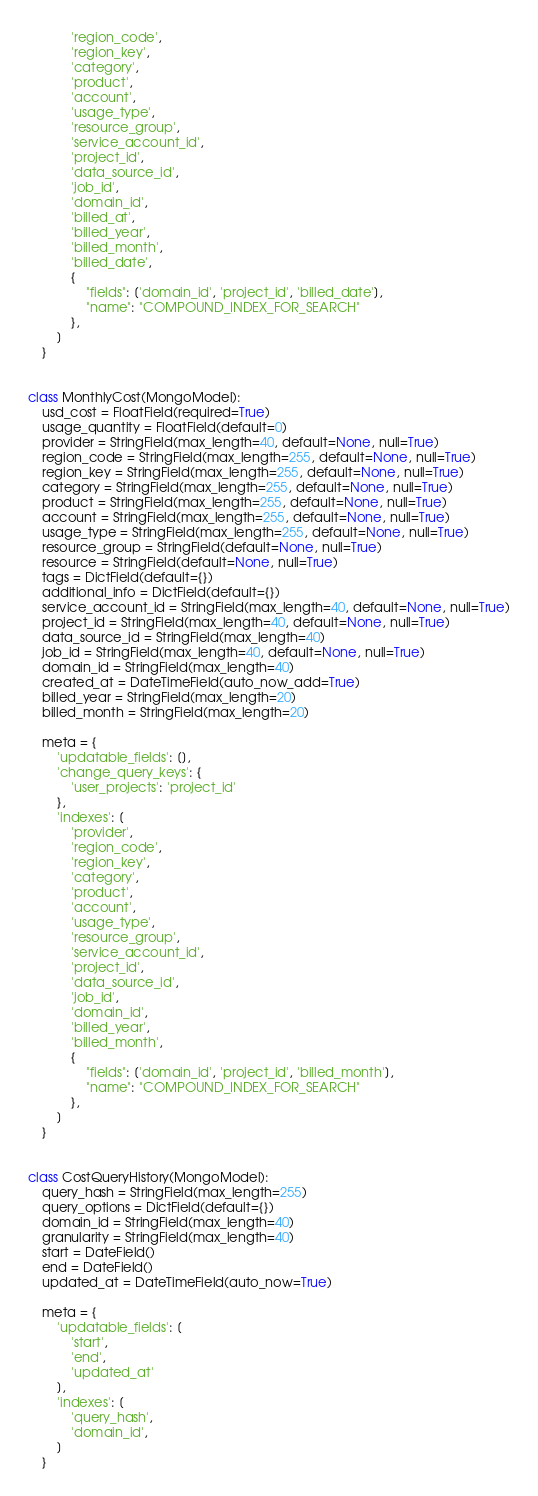<code> <loc_0><loc_0><loc_500><loc_500><_Python_>            'region_code',
            'region_key',
            'category',
            'product',
            'account',
            'usage_type',
            'resource_group',
            'service_account_id',
            'project_id',
            'data_source_id',
            'job_id',
            'domain_id',
            'billed_at',
            'billed_year',
            'billed_month',
            'billed_date',
            {
                "fields": ['domain_id', 'project_id', 'billed_date'],
                "name": "COMPOUND_INDEX_FOR_SEARCH"
            },
        ]
    }


class MonthlyCost(MongoModel):
    usd_cost = FloatField(required=True)
    usage_quantity = FloatField(default=0)
    provider = StringField(max_length=40, default=None, null=True)
    region_code = StringField(max_length=255, default=None, null=True)
    region_key = StringField(max_length=255, default=None, null=True)
    category = StringField(max_length=255, default=None, null=True)
    product = StringField(max_length=255, default=None, null=True)
    account = StringField(max_length=255, default=None, null=True)
    usage_type = StringField(max_length=255, default=None, null=True)
    resource_group = StringField(default=None, null=True)
    resource = StringField(default=None, null=True)
    tags = DictField(default={})
    additional_info = DictField(default={})
    service_account_id = StringField(max_length=40, default=None, null=True)
    project_id = StringField(max_length=40, default=None, null=True)
    data_source_id = StringField(max_length=40)
    job_id = StringField(max_length=40, default=None, null=True)
    domain_id = StringField(max_length=40)
    created_at = DateTimeField(auto_now_add=True)
    billed_year = StringField(max_length=20)
    billed_month = StringField(max_length=20)

    meta = {
        'updatable_fields': [],
        'change_query_keys': {
            'user_projects': 'project_id'
        },
        'indexes': [
            'provider',
            'region_code',
            'region_key',
            'category',
            'product',
            'account',
            'usage_type',
            'resource_group',
            'service_account_id',
            'project_id',
            'data_source_id',
            'job_id',
            'domain_id',
            'billed_year',
            'billed_month',
            {
                "fields": ['domain_id', 'project_id', 'billed_month'],
                "name": "COMPOUND_INDEX_FOR_SEARCH"
            },
        ]
    }


class CostQueryHistory(MongoModel):
    query_hash = StringField(max_length=255)
    query_options = DictField(default={})
    domain_id = StringField(max_length=40)
    granularity = StringField(max_length=40)
    start = DateField()
    end = DateField()
    updated_at = DateTimeField(auto_now=True)

    meta = {
        'updatable_fields': [
            'start',
            'end',
            'updated_at'
        ],
        'indexes': [
            'query_hash',
            'domain_id',
        ]
    }
</code> 